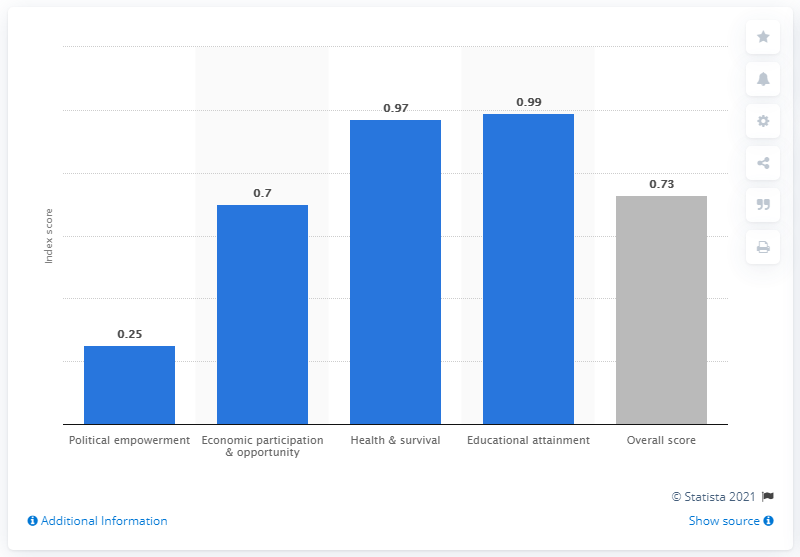Outline some significant characteristics in this image. According to the Global Gender Gap Report 2021, Suriname received a score of 0.25 on political empowerment, indicating limited progress in this area. 